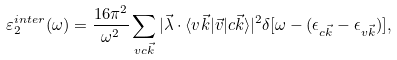<formula> <loc_0><loc_0><loc_500><loc_500>\varepsilon ^ { i n t e r } _ { 2 } ( \omega ) = \frac { 1 6 \pi ^ { 2 } } { \omega ^ { 2 } } \sum _ { v c \vec { k } } | \vec { \lambda } \cdot \langle v \vec { k } | \vec { v } | c \vec { k } \rangle | ^ { 2 } \delta [ \omega - ( \epsilon _ { c \vec { k } } - \epsilon _ { v \vec { k } } ) ] ,</formula> 